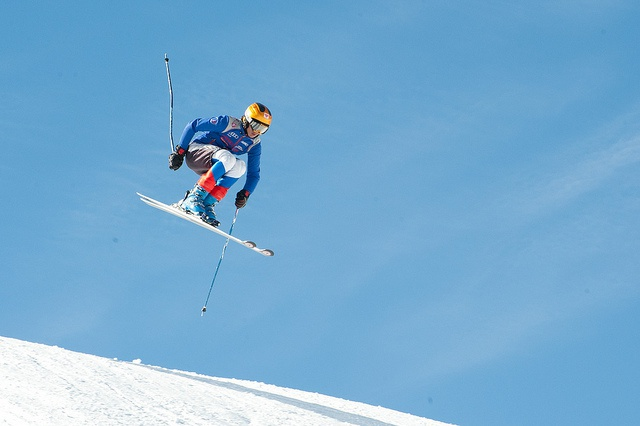Describe the objects in this image and their specific colors. I can see people in lightblue, blue, lightgray, and navy tones and skis in lightblue and lightgray tones in this image. 